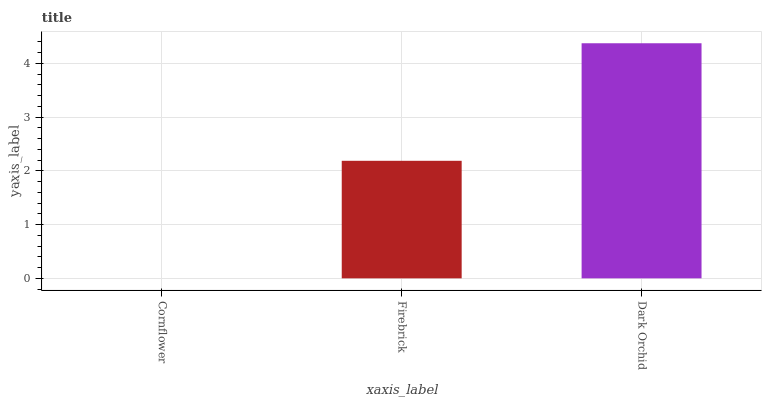Is Cornflower the minimum?
Answer yes or no. Yes. Is Dark Orchid the maximum?
Answer yes or no. Yes. Is Firebrick the minimum?
Answer yes or no. No. Is Firebrick the maximum?
Answer yes or no. No. Is Firebrick greater than Cornflower?
Answer yes or no. Yes. Is Cornflower less than Firebrick?
Answer yes or no. Yes. Is Cornflower greater than Firebrick?
Answer yes or no. No. Is Firebrick less than Cornflower?
Answer yes or no. No. Is Firebrick the high median?
Answer yes or no. Yes. Is Firebrick the low median?
Answer yes or no. Yes. Is Dark Orchid the high median?
Answer yes or no. No. Is Cornflower the low median?
Answer yes or no. No. 